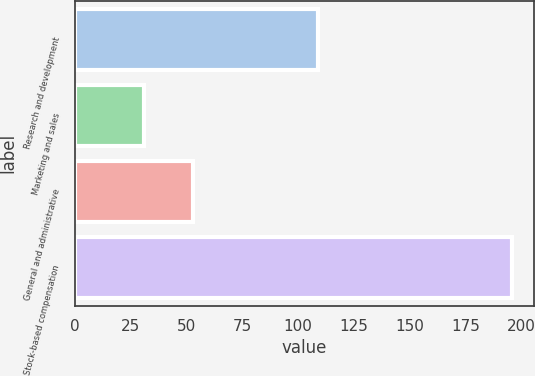Convert chart to OTSL. <chart><loc_0><loc_0><loc_500><loc_500><bar_chart><fcel>Research and development<fcel>Marketing and sales<fcel>General and administrative<fcel>Stock-based compensation<nl><fcel>109<fcel>31<fcel>53<fcel>196<nl></chart> 